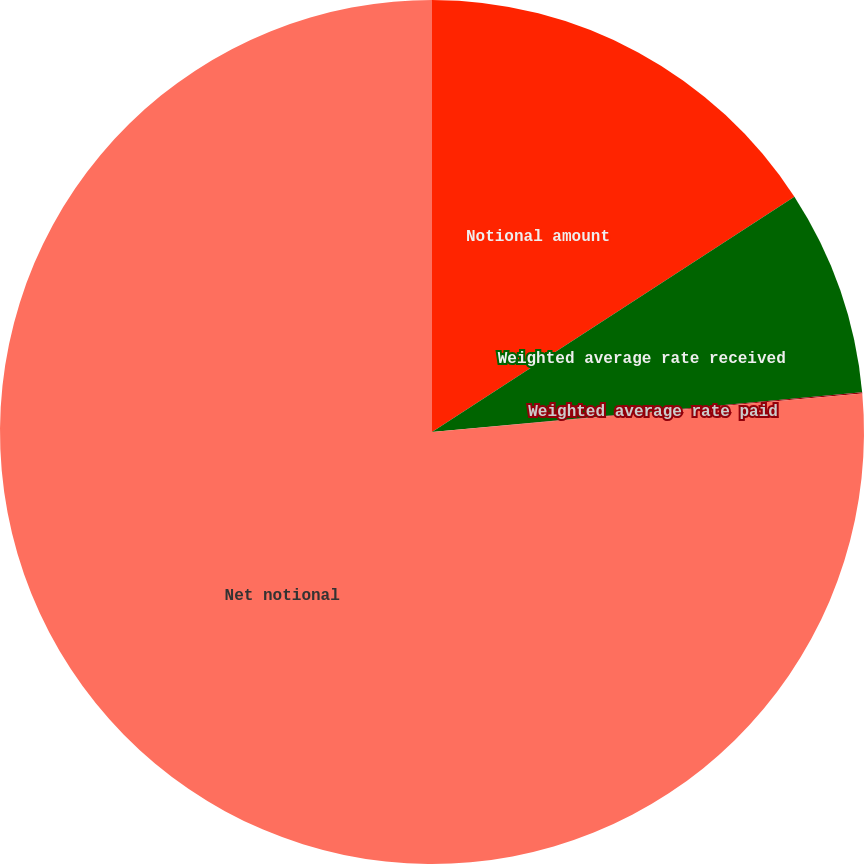Convert chart. <chart><loc_0><loc_0><loc_500><loc_500><pie_chart><fcel>Notional amount<fcel>Weighted average rate received<fcel>Weighted average rate paid<fcel>Net notional<nl><fcel>15.84%<fcel>7.69%<fcel>0.05%<fcel>76.42%<nl></chart> 